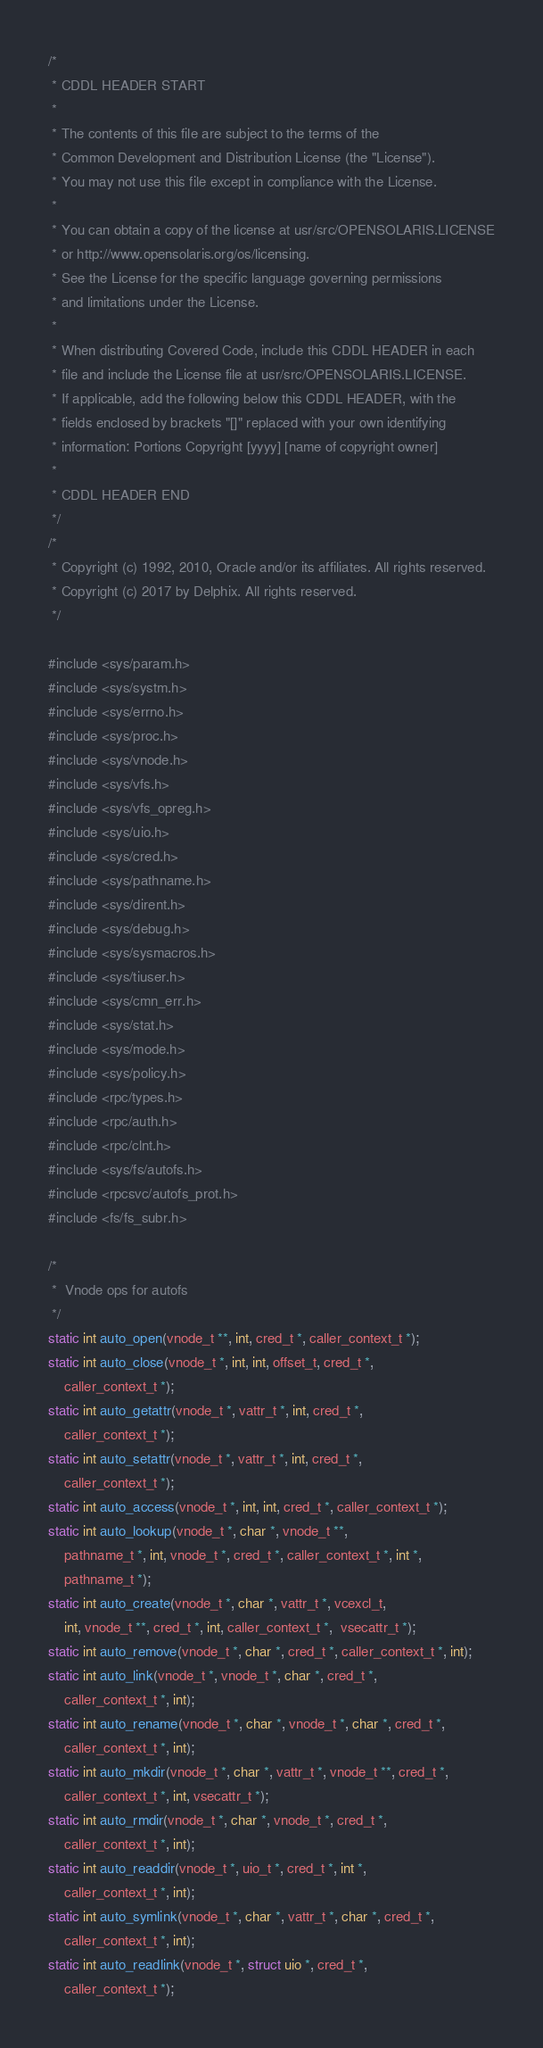Convert code to text. <code><loc_0><loc_0><loc_500><loc_500><_C_>/*
 * CDDL HEADER START
 *
 * The contents of this file are subject to the terms of the
 * Common Development and Distribution License (the "License").
 * You may not use this file except in compliance with the License.
 *
 * You can obtain a copy of the license at usr/src/OPENSOLARIS.LICENSE
 * or http://www.opensolaris.org/os/licensing.
 * See the License for the specific language governing permissions
 * and limitations under the License.
 *
 * When distributing Covered Code, include this CDDL HEADER in each
 * file and include the License file at usr/src/OPENSOLARIS.LICENSE.
 * If applicable, add the following below this CDDL HEADER, with the
 * fields enclosed by brackets "[]" replaced with your own identifying
 * information: Portions Copyright [yyyy] [name of copyright owner]
 *
 * CDDL HEADER END
 */
/*
 * Copyright (c) 1992, 2010, Oracle and/or its affiliates. All rights reserved.
 * Copyright (c) 2017 by Delphix. All rights reserved.
 */

#include <sys/param.h>
#include <sys/systm.h>
#include <sys/errno.h>
#include <sys/proc.h>
#include <sys/vnode.h>
#include <sys/vfs.h>
#include <sys/vfs_opreg.h>
#include <sys/uio.h>
#include <sys/cred.h>
#include <sys/pathname.h>
#include <sys/dirent.h>
#include <sys/debug.h>
#include <sys/sysmacros.h>
#include <sys/tiuser.h>
#include <sys/cmn_err.h>
#include <sys/stat.h>
#include <sys/mode.h>
#include <sys/policy.h>
#include <rpc/types.h>
#include <rpc/auth.h>
#include <rpc/clnt.h>
#include <sys/fs/autofs.h>
#include <rpcsvc/autofs_prot.h>
#include <fs/fs_subr.h>

/*
 *  Vnode ops for autofs
 */
static int auto_open(vnode_t **, int, cred_t *, caller_context_t *);
static int auto_close(vnode_t *, int, int, offset_t, cred_t *,
	caller_context_t *);
static int auto_getattr(vnode_t *, vattr_t *, int, cred_t *,
	caller_context_t *);
static int auto_setattr(vnode_t *, vattr_t *, int, cred_t *,
	caller_context_t *);
static int auto_access(vnode_t *, int, int, cred_t *, caller_context_t *);
static int auto_lookup(vnode_t *, char *, vnode_t **,
	pathname_t *, int, vnode_t *, cred_t *, caller_context_t *, int *,
	pathname_t *);
static int auto_create(vnode_t *, char *, vattr_t *, vcexcl_t,
	int, vnode_t **, cred_t *, int, caller_context_t *,  vsecattr_t *);
static int auto_remove(vnode_t *, char *, cred_t *, caller_context_t *, int);
static int auto_link(vnode_t *, vnode_t *, char *, cred_t *,
	caller_context_t *, int);
static int auto_rename(vnode_t *, char *, vnode_t *, char *, cred_t *,
	caller_context_t *, int);
static int auto_mkdir(vnode_t *, char *, vattr_t *, vnode_t **, cred_t *,
	caller_context_t *, int, vsecattr_t *);
static int auto_rmdir(vnode_t *, char *, vnode_t *, cred_t *,
	caller_context_t *, int);
static int auto_readdir(vnode_t *, uio_t *, cred_t *, int *,
	caller_context_t *, int);
static int auto_symlink(vnode_t *, char *, vattr_t *, char *, cred_t *,
	caller_context_t *, int);
static int auto_readlink(vnode_t *, struct uio *, cred_t *,
	caller_context_t *);</code> 